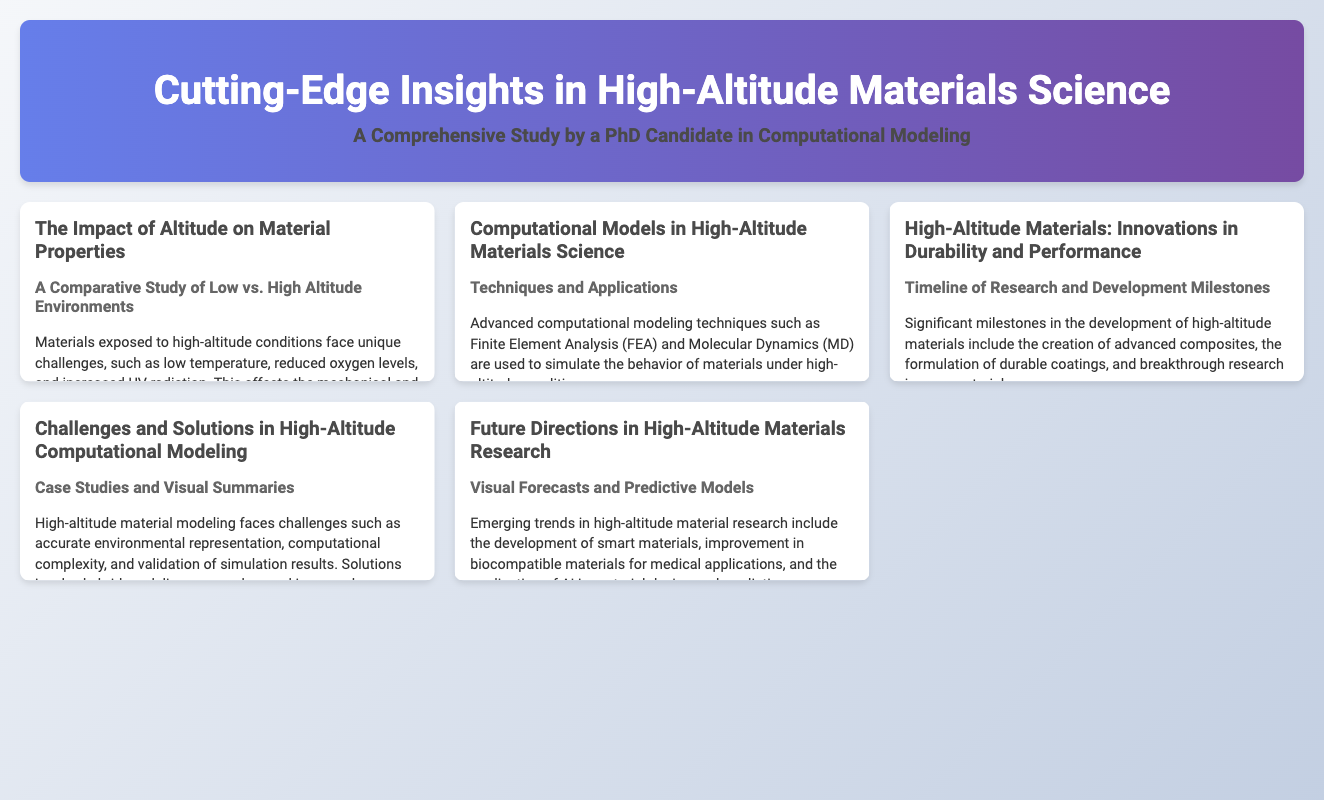What are the unique challenges faced by materials at high altitude? The document mentions low temperature, reduced oxygen levels, and increased UV radiation as unique challenges.
Answer: Low temperature, reduced oxygen levels, increased UV radiation What advanced techniques are used in computational modeling for high-altitude materials? The document states that Finite Element Analysis (FEA) and Molecular Dynamics (MD) are the advanced techniques used.
Answer: Finite Element Analysis (FEA), Molecular Dynamics (MD) Which milestone is related to the development of durable coatings? The document lists milestones in high-altitude materials, including the formulation of durable coatings.
Answer: Formulation of durable coatings What is a significant challenge in high-altitude material modeling? The document highlights accurate environmental representation, computational complexity, and validation of simulation results as challenges.
Answer: Accurate environmental representation What emerging trend focuses on medical applications in high-altitude materials research? The document mentions improvement in biocompatible materials for medical applications as an emerging trend.
Answer: Improvement in biocompatible materials for medical applications What does the flowchart in the computational models section illustrate? The flowchart illustrates the FEA Workflow for High-Altitude Simulation.
Answer: FEA Workflow for High-Altitude Simulation What is depicted in the timeline section regarding high-altitude materials? The timeline shows a timeline of research and development milestones in high-altitude materials.
Answer: Timeline of research and development milestones What case study is presented in the challenges section? The document provides a case study on modeling thermal stress on aircraft components.
Answer: Modeling thermal stress on aircraft components 